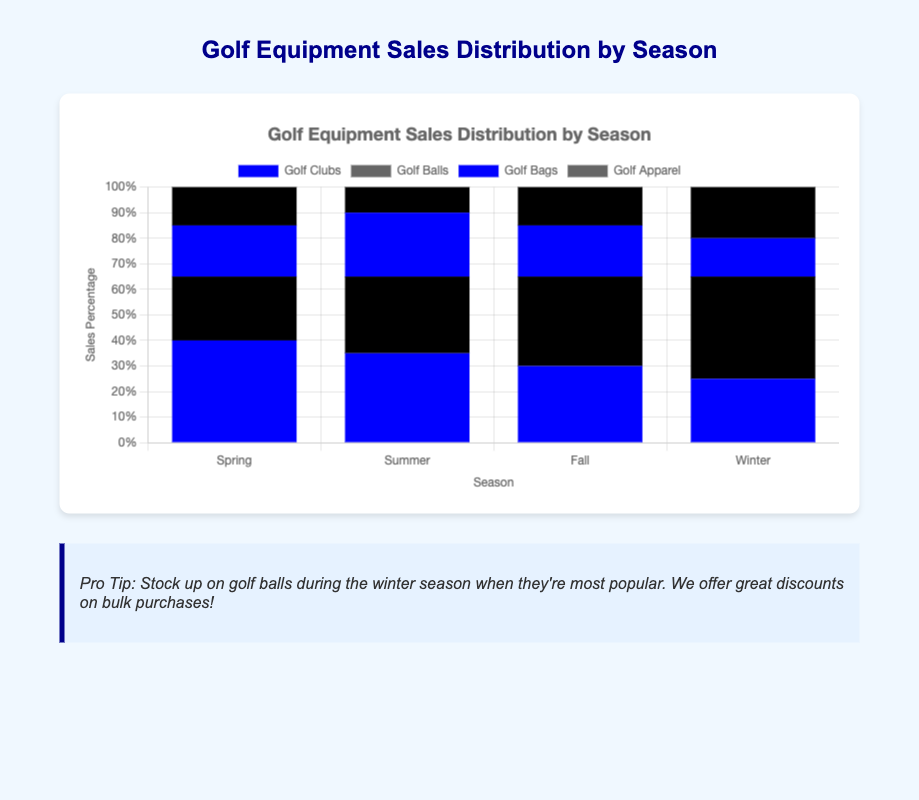How do sales percentages of golf clubs change from Spring to Winter? To find the answer, look at the height of the blue bars for each season. Spring is 40%, Summer is 35%, Fall is 30%, and Winter is 25%. The sales percentage of golf clubs decreases steadily from Spring to Winter.
Answer: They decrease steadily What's the most popular golf equipment category in Fall? Look for the category with the tallest bar in Fall. Golf Balls (dark blue) have the highest percentage at 35%.
Answer: Golf Balls Which season has the highest sales percentage for golf balls? Identify the tallest dark blue bar representing Golf Balls. Winter has the tallest bar at 40%.
Answer: Winter What is the total sales percentage for all categories in Summer? Sum the sales percentages for each category in Summer: 35% (Golf Clubs) + 30% (Golf Balls) + 25% (Golf Bags) + 10% (Golf Apparel).
Answer: 100% Compare the sales percentages of Golf Apparel between Spring and Winter. Which season has higher sales? Check the dark blue bars for Golf Apparel in both seasons. Spring is 15% and Winter is 20%. Winter has higher sales.
Answer: Winter What percentage more of Golf Balls are sold in Winter compared to Spring? Subtract the sales percentage of Golf Balls in Spring from Winter: 40% (Winter) - 25% (Spring).
Answer: 15% Which season(s) have the same sales percentage for Golf Bags? Look for seasons where the blue bars for Golf Bags are of equal height. Spring (20%) and Fall (20%).
Answer: Spring and Fall What's the average sales percentage for Golf Clubs across all seasons? Sum the sales percentages for Golf Clubs over all seasons and divide by 4: (40% + 35% + 30% + 25%) / 4
Answer: 32.5% Is Golf Apparel more popular in Fall or Summer? Compare the heights of the dark blue bars for Golf Apparel in Fall (15%) and Summer (10%).
Answer: Fall How do sales percentages for Golf Clubs and Golf Balls compare in Winter? Compare the heights of the blue (Golf Clubs) and dark blue (Golf Balls) bars in Winter. Golf Balls have 40% and Golf Clubs have 25%.
Answer: Golf Balls have higher sales 